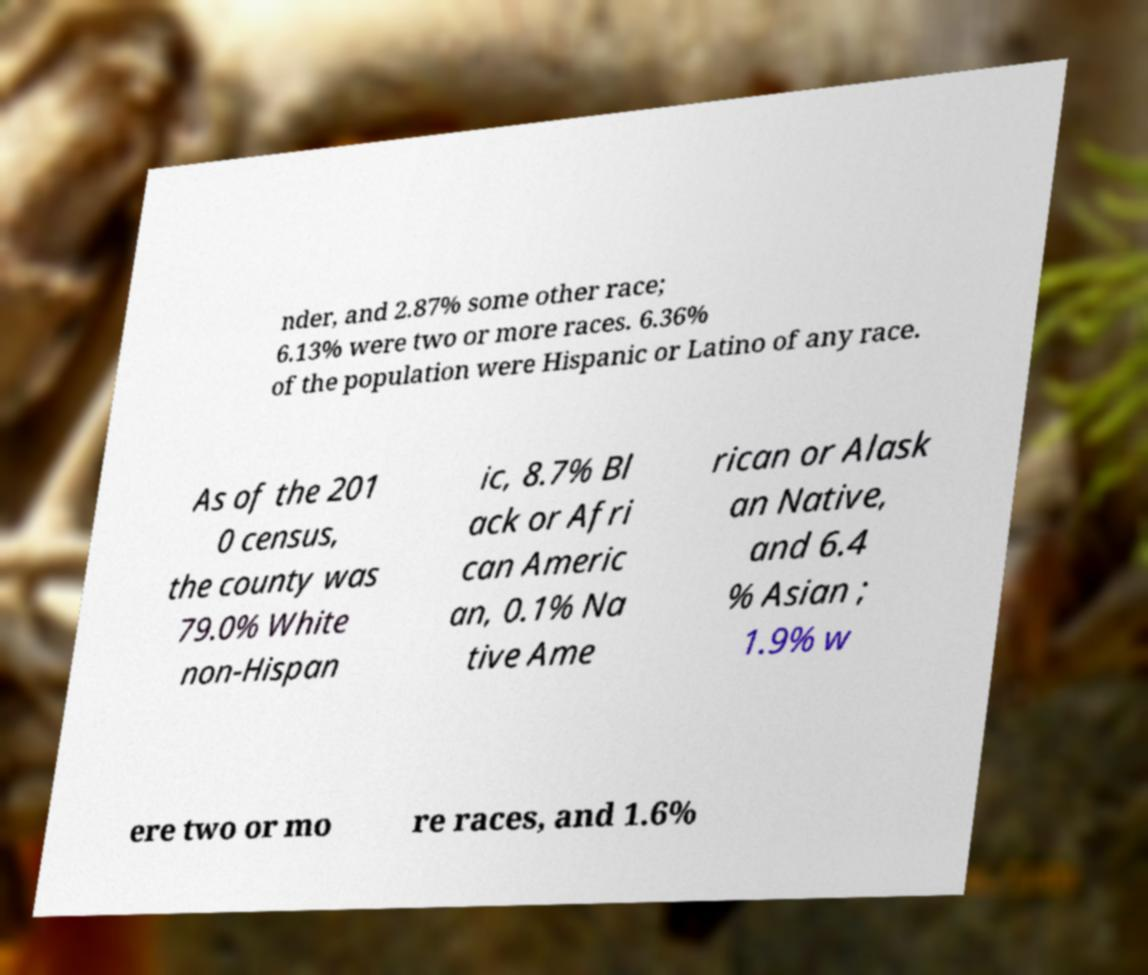For documentation purposes, I need the text within this image transcribed. Could you provide that? nder, and 2.87% some other race; 6.13% were two or more races. 6.36% of the population were Hispanic or Latino of any race. As of the 201 0 census, the county was 79.0% White non-Hispan ic, 8.7% Bl ack or Afri can Americ an, 0.1% Na tive Ame rican or Alask an Native, and 6.4 % Asian ; 1.9% w ere two or mo re races, and 1.6% 